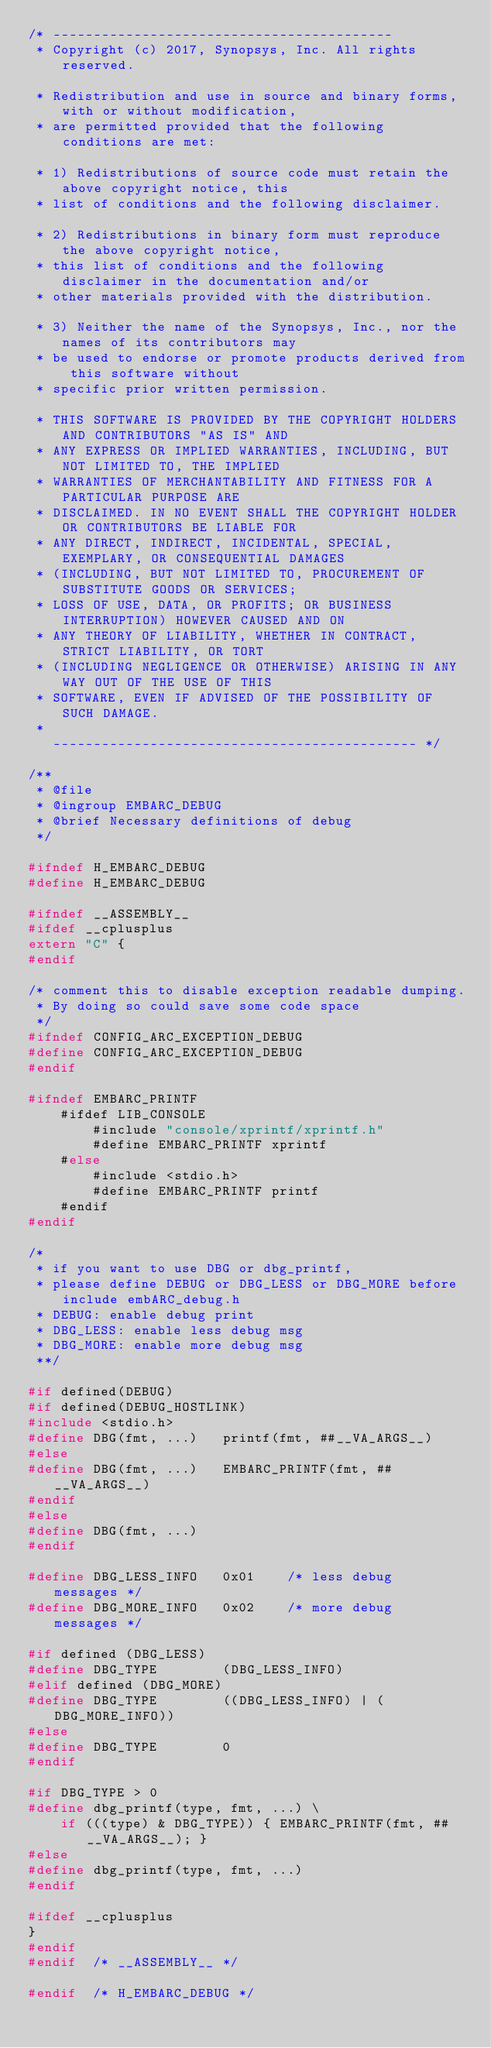Convert code to text. <code><loc_0><loc_0><loc_500><loc_500><_C_>/* ------------------------------------------
 * Copyright (c) 2017, Synopsys, Inc. All rights reserved.

 * Redistribution and use in source and binary forms, with or without modification,
 * are permitted provided that the following conditions are met:

 * 1) Redistributions of source code must retain the above copyright notice, this
 * list of conditions and the following disclaimer.

 * 2) Redistributions in binary form must reproduce the above copyright notice,
 * this list of conditions and the following disclaimer in the documentation and/or
 * other materials provided with the distribution.

 * 3) Neither the name of the Synopsys, Inc., nor the names of its contributors may
 * be used to endorse or promote products derived from this software without
 * specific prior written permission.

 * THIS SOFTWARE IS PROVIDED BY THE COPYRIGHT HOLDERS AND CONTRIBUTORS "AS IS" AND
 * ANY EXPRESS OR IMPLIED WARRANTIES, INCLUDING, BUT NOT LIMITED TO, THE IMPLIED
 * WARRANTIES OF MERCHANTABILITY AND FITNESS FOR A PARTICULAR PURPOSE ARE
 * DISCLAIMED. IN NO EVENT SHALL THE COPYRIGHT HOLDER OR CONTRIBUTORS BE LIABLE FOR
 * ANY DIRECT, INDIRECT, INCIDENTAL, SPECIAL, EXEMPLARY, OR CONSEQUENTIAL DAMAGES
 * (INCLUDING, BUT NOT LIMITED TO, PROCUREMENT OF SUBSTITUTE GOODS OR SERVICES;
 * LOSS OF USE, DATA, OR PROFITS; OR BUSINESS INTERRUPTION) HOWEVER CAUSED AND ON
 * ANY THEORY OF LIABILITY, WHETHER IN CONTRACT, STRICT LIABILITY, OR TORT
 * (INCLUDING NEGLIGENCE OR OTHERWISE) ARISING IN ANY WAY OUT OF THE USE OF THIS
 * SOFTWARE, EVEN IF ADVISED OF THE POSSIBILITY OF SUCH DAMAGE.
 *
   --------------------------------------------- */

/**
 * @file
 * @ingroup EMBARC_DEBUG
 * @brief Necessary definitions of debug
 */

#ifndef H_EMBARC_DEBUG
#define H_EMBARC_DEBUG

#ifndef __ASSEMBLY__
#ifdef __cplusplus
extern "C" {
#endif

/* comment this to disable exception readable dumping.
 * By doing so could save some code space
 */
#ifndef CONFIG_ARC_EXCEPTION_DEBUG
#define CONFIG_ARC_EXCEPTION_DEBUG
#endif

#ifndef EMBARC_PRINTF
	#ifdef LIB_CONSOLE
		#include "console/xprintf/xprintf.h"
		#define EMBARC_PRINTF xprintf
	#else
		#include <stdio.h>
		#define EMBARC_PRINTF printf
	#endif
#endif

/*
 * if you want to use DBG or dbg_printf,
 * please define DEBUG or DBG_LESS or DBG_MORE before include embARC_debug.h
 * DEBUG: enable debug print
 * DBG_LESS: enable less debug msg
 * DBG_MORE: enable more debug msg
 **/

#if defined(DEBUG)
#if defined(DEBUG_HOSTLINK)
#include <stdio.h>
#define DBG(fmt, ...)   printf(fmt, ##__VA_ARGS__)
#else
#define DBG(fmt, ...)   EMBARC_PRINTF(fmt, ##__VA_ARGS__)
#endif
#else
#define DBG(fmt, ...)
#endif

#define DBG_LESS_INFO   0x01    /* less debug  messages */
#define DBG_MORE_INFO   0x02    /* more debug  messages */

#if defined (DBG_LESS)
#define DBG_TYPE        (DBG_LESS_INFO)
#elif defined (DBG_MORE)
#define DBG_TYPE        ((DBG_LESS_INFO) | (DBG_MORE_INFO))
#else
#define DBG_TYPE        0
#endif

#if DBG_TYPE > 0
#define dbg_printf(type, fmt, ...) \
	if (((type) & DBG_TYPE)) { EMBARC_PRINTF(fmt, ##__VA_ARGS__); }
#else
#define dbg_printf(type, fmt, ...)
#endif

#ifdef __cplusplus
}
#endif
#endif  /* __ASSEMBLY__ */

#endif  /* H_EMBARC_DEBUG */
</code> 